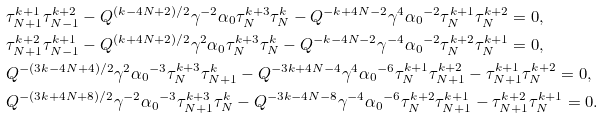Convert formula to latex. <formula><loc_0><loc_0><loc_500><loc_500>& \tau ^ { k + 1 } _ { N + 1 } \tau ^ { k + 2 } _ { N - 1 } - Q ^ { ( k - 4 N + 2 ) / 2 } \gamma ^ { - 2 } \alpha _ { 0 } \tau ^ { k + 3 } _ { N } \tau ^ { k } _ { N } - Q ^ { - k + 4 N - 2 } \gamma ^ { 4 } { \alpha _ { 0 } } ^ { - 2 } \tau ^ { k + 1 } _ { N } \tau ^ { k + 2 } _ { N } = 0 , \\ & \tau ^ { k + 2 } _ { N + 1 } \tau ^ { k + 1 } _ { N - 1 } - Q ^ { ( k + 4 N + 2 ) / 2 } \gamma ^ { 2 } \alpha _ { 0 } \tau ^ { k + 3 } _ { N } \tau ^ { k } _ { N } - Q ^ { - k - 4 N - 2 } \gamma ^ { - 4 } { \alpha _ { 0 } } ^ { - 2 } \tau ^ { k + 2 } _ { N } \tau ^ { k + 1 } _ { N } = 0 , \\ & Q ^ { - ( 3 k - 4 N + 4 ) / 2 } \gamma ^ { 2 } { \alpha _ { 0 } } ^ { - 3 } \tau ^ { k + 3 } _ { N } \tau ^ { k } _ { N + 1 } - Q ^ { - 3 k + 4 N - 4 } \gamma ^ { 4 } { \alpha _ { 0 } } ^ { - 6 } \tau ^ { k + 1 } _ { N } \tau ^ { k + 2 } _ { N + 1 } - \tau ^ { k + 1 } _ { N + 1 } \tau ^ { k + 2 } _ { N } = 0 , \\ & Q ^ { - ( 3 k + 4 N + 8 ) / 2 } \gamma ^ { - 2 } { \alpha _ { 0 } } ^ { - 3 } \tau ^ { k + 3 } _ { N + 1 } \tau ^ { k } _ { N } - Q ^ { - 3 k - 4 N - 8 } \gamma ^ { - 4 } { \alpha _ { 0 } } ^ { - 6 } \tau ^ { k + 2 } _ { N } \tau ^ { k + 1 } _ { N + 1 } - \tau ^ { k + 2 } _ { N + 1 } \tau ^ { k + 1 } _ { N } = 0 .</formula> 